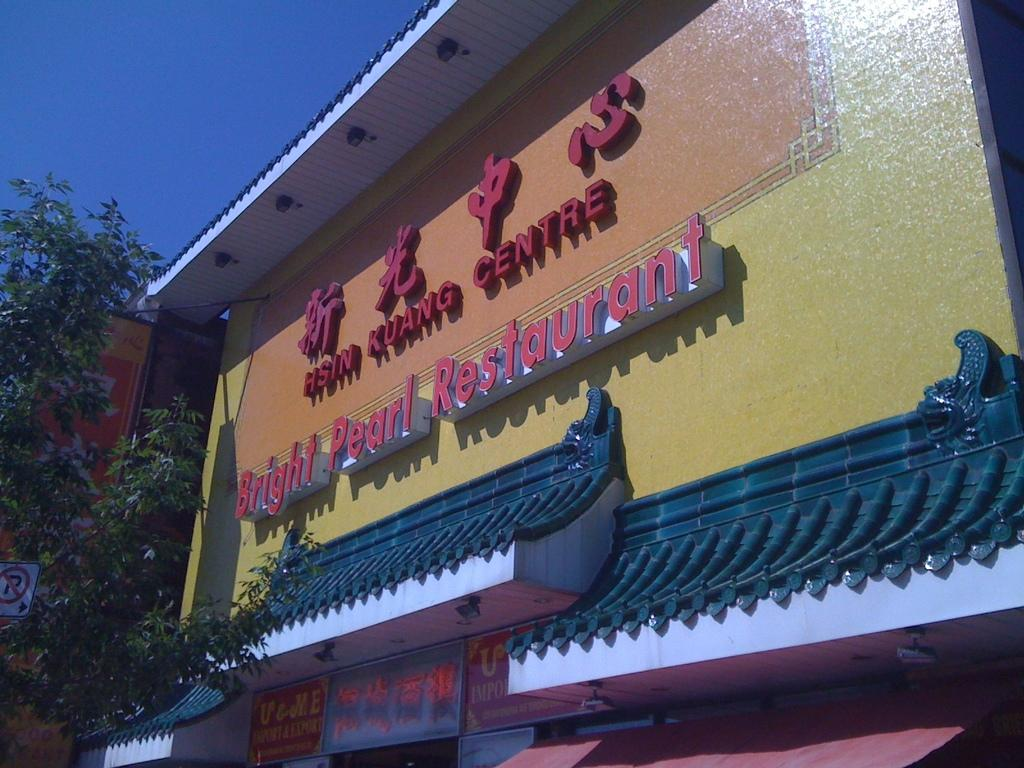<image>
Present a compact description of the photo's key features. A sign that promotes the Bright Pearl Restaurant. 